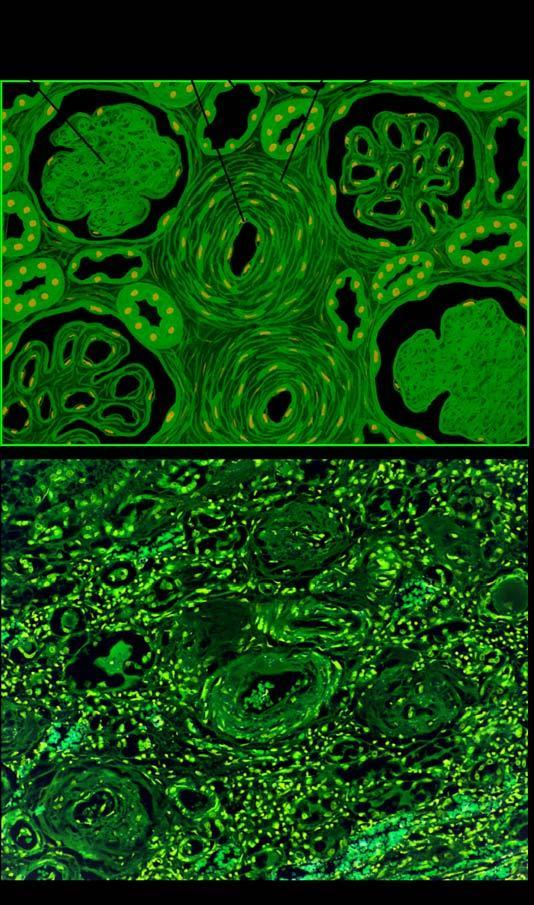re congo red staining hyaline arteriolosclerosis and intimal thickening of small blood vessels in the glomerular tuft?
Answer the question using a single word or phrase. No 